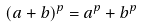Convert formula to latex. <formula><loc_0><loc_0><loc_500><loc_500>( a + b ) ^ { p } = a ^ { p } + b ^ { p }</formula> 